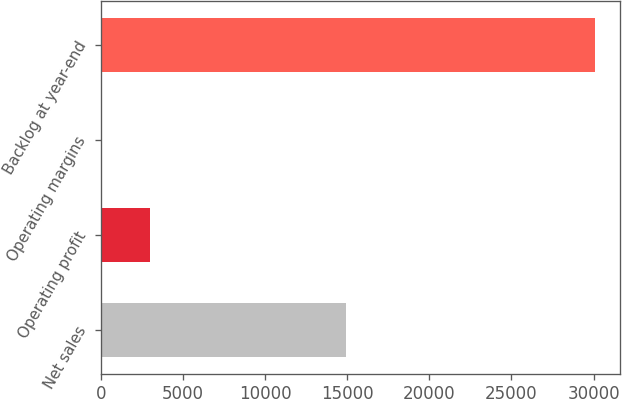Convert chart. <chart><loc_0><loc_0><loc_500><loc_500><bar_chart><fcel>Net sales<fcel>Operating profit<fcel>Operating margins<fcel>Backlog at year-end<nl><fcel>14953<fcel>3020.26<fcel>11.4<fcel>30100<nl></chart> 